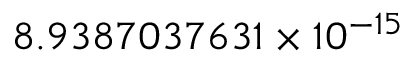Convert formula to latex. <formula><loc_0><loc_0><loc_500><loc_500>8 . 9 3 8 7 0 3 7 6 3 1 \times 1 0 ^ { - 1 5 }</formula> 